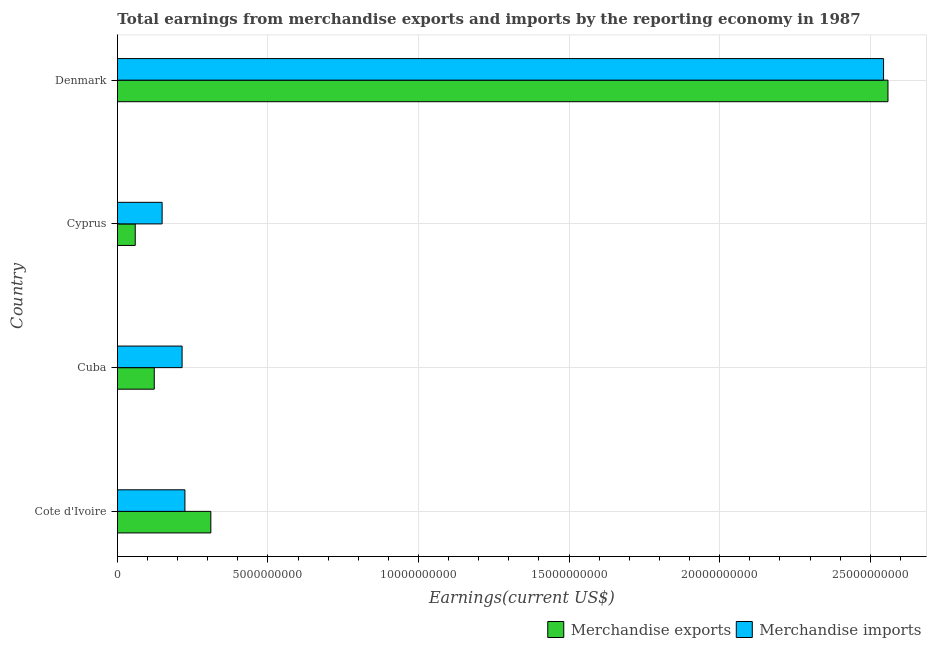How many groups of bars are there?
Offer a terse response. 4. Are the number of bars per tick equal to the number of legend labels?
Your answer should be compact. Yes. Are the number of bars on each tick of the Y-axis equal?
Give a very brief answer. Yes. What is the label of the 2nd group of bars from the top?
Your answer should be compact. Cyprus. What is the earnings from merchandise imports in Cyprus?
Your response must be concise. 1.49e+09. Across all countries, what is the maximum earnings from merchandise imports?
Offer a terse response. 2.54e+1. Across all countries, what is the minimum earnings from merchandise imports?
Offer a terse response. 1.49e+09. In which country was the earnings from merchandise imports maximum?
Give a very brief answer. Denmark. In which country was the earnings from merchandise exports minimum?
Your response must be concise. Cyprus. What is the total earnings from merchandise exports in the graph?
Ensure brevity in your answer.  3.05e+1. What is the difference between the earnings from merchandise imports in Cote d'Ivoire and that in Denmark?
Provide a succinct answer. -2.32e+1. What is the difference between the earnings from merchandise imports in Cuba and the earnings from merchandise exports in Denmark?
Provide a succinct answer. -2.34e+1. What is the average earnings from merchandise imports per country?
Your answer should be compact. 7.83e+09. What is the difference between the earnings from merchandise exports and earnings from merchandise imports in Cuba?
Ensure brevity in your answer.  -9.24e+08. In how many countries, is the earnings from merchandise exports greater than 22000000000 US$?
Keep it short and to the point. 1. What is the ratio of the earnings from merchandise exports in Cote d'Ivoire to that in Cyprus?
Offer a very short reply. 5.24. Is the earnings from merchandise exports in Cuba less than that in Cyprus?
Make the answer very short. No. Is the difference between the earnings from merchandise exports in Cuba and Cyprus greater than the difference between the earnings from merchandise imports in Cuba and Cyprus?
Make the answer very short. No. What is the difference between the highest and the second highest earnings from merchandise exports?
Your answer should be compact. 2.25e+1. What is the difference between the highest and the lowest earnings from merchandise imports?
Your answer should be very brief. 2.40e+1. In how many countries, is the earnings from merchandise exports greater than the average earnings from merchandise exports taken over all countries?
Your response must be concise. 1. What does the 1st bar from the top in Denmark represents?
Provide a short and direct response. Merchandise imports. What does the 2nd bar from the bottom in Cuba represents?
Ensure brevity in your answer.  Merchandise imports. How many bars are there?
Give a very brief answer. 8. What is the difference between two consecutive major ticks on the X-axis?
Keep it short and to the point. 5.00e+09. Does the graph contain grids?
Provide a short and direct response. Yes. Where does the legend appear in the graph?
Offer a terse response. Bottom right. What is the title of the graph?
Offer a very short reply. Total earnings from merchandise exports and imports by the reporting economy in 1987. What is the label or title of the X-axis?
Ensure brevity in your answer.  Earnings(current US$). What is the Earnings(current US$) in Merchandise exports in Cote d'Ivoire?
Offer a terse response. 3.10e+09. What is the Earnings(current US$) of Merchandise imports in Cote d'Ivoire?
Ensure brevity in your answer.  2.24e+09. What is the Earnings(current US$) of Merchandise exports in Cuba?
Make the answer very short. 1.22e+09. What is the Earnings(current US$) in Merchandise imports in Cuba?
Ensure brevity in your answer.  2.15e+09. What is the Earnings(current US$) of Merchandise exports in Cyprus?
Give a very brief answer. 5.92e+08. What is the Earnings(current US$) of Merchandise imports in Cyprus?
Ensure brevity in your answer.  1.49e+09. What is the Earnings(current US$) in Merchandise exports in Denmark?
Provide a short and direct response. 2.56e+1. What is the Earnings(current US$) of Merchandise imports in Denmark?
Make the answer very short. 2.54e+1. Across all countries, what is the maximum Earnings(current US$) of Merchandise exports?
Provide a short and direct response. 2.56e+1. Across all countries, what is the maximum Earnings(current US$) in Merchandise imports?
Keep it short and to the point. 2.54e+1. Across all countries, what is the minimum Earnings(current US$) in Merchandise exports?
Your response must be concise. 5.92e+08. Across all countries, what is the minimum Earnings(current US$) in Merchandise imports?
Offer a terse response. 1.49e+09. What is the total Earnings(current US$) in Merchandise exports in the graph?
Give a very brief answer. 3.05e+1. What is the total Earnings(current US$) in Merchandise imports in the graph?
Provide a succinct answer. 3.13e+1. What is the difference between the Earnings(current US$) in Merchandise exports in Cote d'Ivoire and that in Cuba?
Provide a succinct answer. 1.88e+09. What is the difference between the Earnings(current US$) of Merchandise imports in Cote d'Ivoire and that in Cuba?
Offer a very short reply. 9.43e+07. What is the difference between the Earnings(current US$) in Merchandise exports in Cote d'Ivoire and that in Cyprus?
Provide a short and direct response. 2.51e+09. What is the difference between the Earnings(current US$) of Merchandise imports in Cote d'Ivoire and that in Cyprus?
Provide a short and direct response. 7.57e+08. What is the difference between the Earnings(current US$) of Merchandise exports in Cote d'Ivoire and that in Denmark?
Offer a very short reply. -2.25e+1. What is the difference between the Earnings(current US$) of Merchandise imports in Cote d'Ivoire and that in Denmark?
Ensure brevity in your answer.  -2.32e+1. What is the difference between the Earnings(current US$) in Merchandise exports in Cuba and that in Cyprus?
Provide a succinct answer. 6.32e+08. What is the difference between the Earnings(current US$) of Merchandise imports in Cuba and that in Cyprus?
Make the answer very short. 6.63e+08. What is the difference between the Earnings(current US$) in Merchandise exports in Cuba and that in Denmark?
Give a very brief answer. -2.44e+1. What is the difference between the Earnings(current US$) in Merchandise imports in Cuba and that in Denmark?
Make the answer very short. -2.33e+1. What is the difference between the Earnings(current US$) in Merchandise exports in Cyprus and that in Denmark?
Make the answer very short. -2.50e+1. What is the difference between the Earnings(current US$) in Merchandise imports in Cyprus and that in Denmark?
Offer a terse response. -2.40e+1. What is the difference between the Earnings(current US$) of Merchandise exports in Cote d'Ivoire and the Earnings(current US$) of Merchandise imports in Cuba?
Give a very brief answer. 9.55e+08. What is the difference between the Earnings(current US$) in Merchandise exports in Cote d'Ivoire and the Earnings(current US$) in Merchandise imports in Cyprus?
Your answer should be very brief. 1.62e+09. What is the difference between the Earnings(current US$) of Merchandise exports in Cote d'Ivoire and the Earnings(current US$) of Merchandise imports in Denmark?
Your answer should be very brief. -2.23e+1. What is the difference between the Earnings(current US$) of Merchandise exports in Cuba and the Earnings(current US$) of Merchandise imports in Cyprus?
Your response must be concise. -2.61e+08. What is the difference between the Earnings(current US$) of Merchandise exports in Cuba and the Earnings(current US$) of Merchandise imports in Denmark?
Offer a very short reply. -2.42e+1. What is the difference between the Earnings(current US$) of Merchandise exports in Cyprus and the Earnings(current US$) of Merchandise imports in Denmark?
Your answer should be very brief. -2.49e+1. What is the average Earnings(current US$) of Merchandise exports per country?
Provide a short and direct response. 7.63e+09. What is the average Earnings(current US$) of Merchandise imports per country?
Provide a succinct answer. 7.83e+09. What is the difference between the Earnings(current US$) of Merchandise exports and Earnings(current US$) of Merchandise imports in Cote d'Ivoire?
Provide a succinct answer. 8.61e+08. What is the difference between the Earnings(current US$) of Merchandise exports and Earnings(current US$) of Merchandise imports in Cuba?
Offer a very short reply. -9.24e+08. What is the difference between the Earnings(current US$) in Merchandise exports and Earnings(current US$) in Merchandise imports in Cyprus?
Keep it short and to the point. -8.93e+08. What is the difference between the Earnings(current US$) of Merchandise exports and Earnings(current US$) of Merchandise imports in Denmark?
Your answer should be compact. 1.46e+08. What is the ratio of the Earnings(current US$) in Merchandise exports in Cote d'Ivoire to that in Cuba?
Offer a very short reply. 2.53. What is the ratio of the Earnings(current US$) in Merchandise imports in Cote d'Ivoire to that in Cuba?
Keep it short and to the point. 1.04. What is the ratio of the Earnings(current US$) in Merchandise exports in Cote d'Ivoire to that in Cyprus?
Keep it short and to the point. 5.24. What is the ratio of the Earnings(current US$) in Merchandise imports in Cote d'Ivoire to that in Cyprus?
Provide a short and direct response. 1.51. What is the ratio of the Earnings(current US$) of Merchandise exports in Cote d'Ivoire to that in Denmark?
Your answer should be compact. 0.12. What is the ratio of the Earnings(current US$) of Merchandise imports in Cote d'Ivoire to that in Denmark?
Your answer should be compact. 0.09. What is the ratio of the Earnings(current US$) in Merchandise exports in Cuba to that in Cyprus?
Your answer should be very brief. 2.07. What is the ratio of the Earnings(current US$) in Merchandise imports in Cuba to that in Cyprus?
Make the answer very short. 1.45. What is the ratio of the Earnings(current US$) in Merchandise exports in Cuba to that in Denmark?
Offer a terse response. 0.05. What is the ratio of the Earnings(current US$) of Merchandise imports in Cuba to that in Denmark?
Provide a succinct answer. 0.08. What is the ratio of the Earnings(current US$) of Merchandise exports in Cyprus to that in Denmark?
Give a very brief answer. 0.02. What is the ratio of the Earnings(current US$) in Merchandise imports in Cyprus to that in Denmark?
Give a very brief answer. 0.06. What is the difference between the highest and the second highest Earnings(current US$) in Merchandise exports?
Provide a succinct answer. 2.25e+1. What is the difference between the highest and the second highest Earnings(current US$) in Merchandise imports?
Provide a short and direct response. 2.32e+1. What is the difference between the highest and the lowest Earnings(current US$) in Merchandise exports?
Provide a short and direct response. 2.50e+1. What is the difference between the highest and the lowest Earnings(current US$) of Merchandise imports?
Provide a short and direct response. 2.40e+1. 